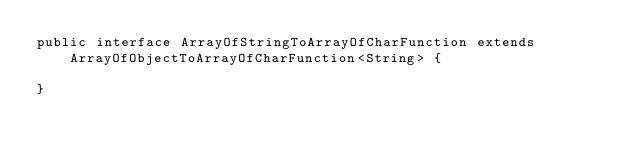<code> <loc_0><loc_0><loc_500><loc_500><_Java_>public interface ArrayOfStringToArrayOfCharFunction extends ArrayOfObjectToArrayOfCharFunction<String> {

}
</code> 